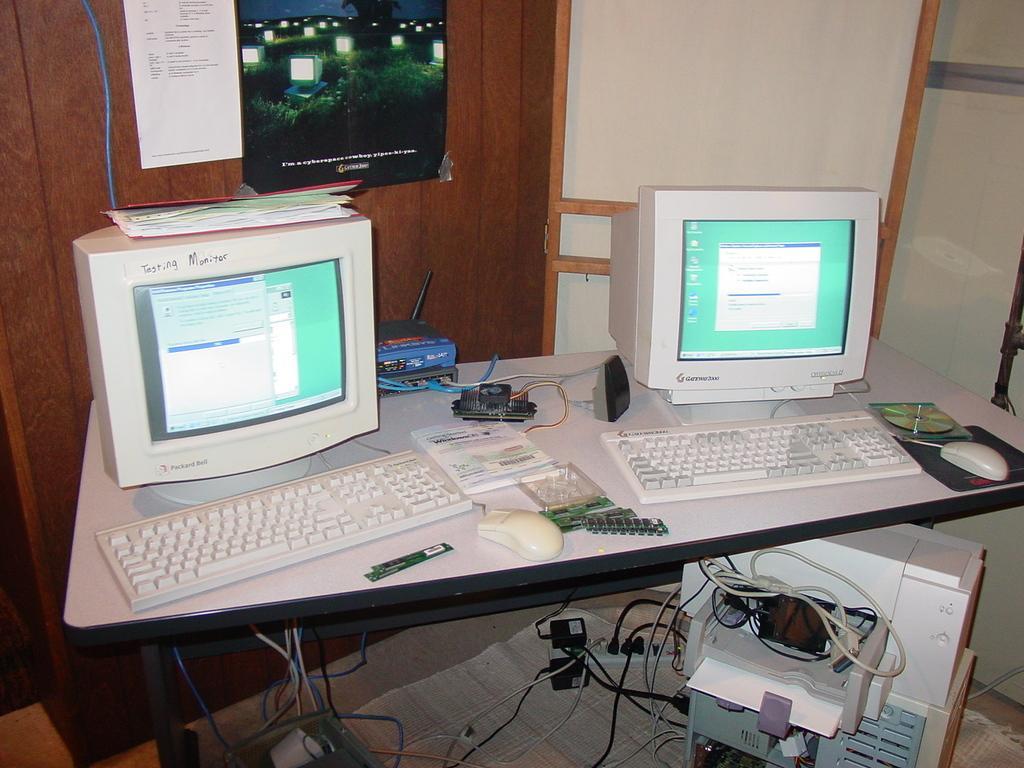Describe this image in one or two sentences. In the picture there are two computers,CD,motherboard,router,kept on a white table,beside the table there is a CPU on the ground left side there is a switch board,in the background there is a wooden wall and a paper stick to the wall,beside that there is photo frame. 